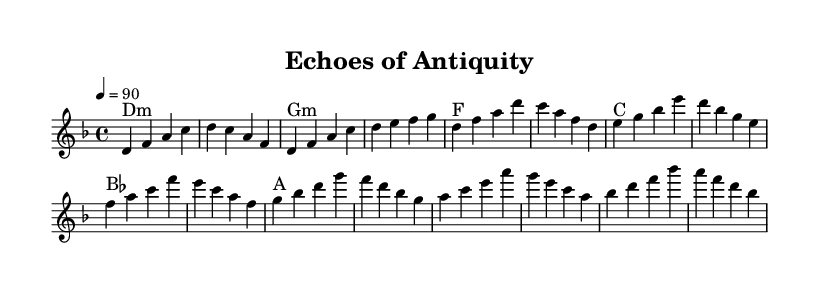What is the key signature of this music? The key signature is D minor, which has one flat (B flat). This can be determined from the global section of the code where the key is specified as "d \minor".
Answer: D minor What is the time signature of this piece? The time signature is 4/4, as indicated in the global section of the code with the specification "\time 4/4". This means there are four beats in each measure.
Answer: 4/4 What is the tempo marking for this piece? The tempo marking is 90 beats per minute, seen in the global section under the tempo directive "\tempo 4 = 90". This sets the speed at which the music should be played.
Answer: 90 What chord precedes the chorus? The chord preceding the chorus is an F major chord, which is indicated in the harmony section as the last chord of the verse before the chorus starts. It follows the pattern of the music where the chord changes are outlined.
Answer: F What is the predominant theme suggested by the title "Echoes of Antiquity"? The predominant theme suggested is archaeological discoveries and ancient civilizations, as indicated by the title itself which reflects a connection to the past and potentially explores sounds that evoke ancient historical contexts.
Answer: Archaeological discoveries What melodic element is repeated throughout the piece? The melodic element repeated is the pattern of notes in the verse, which includes the notes d, f, and a. This repetition reinforces the structure and builds familiarity within the piece.
Answer: d, f, a 